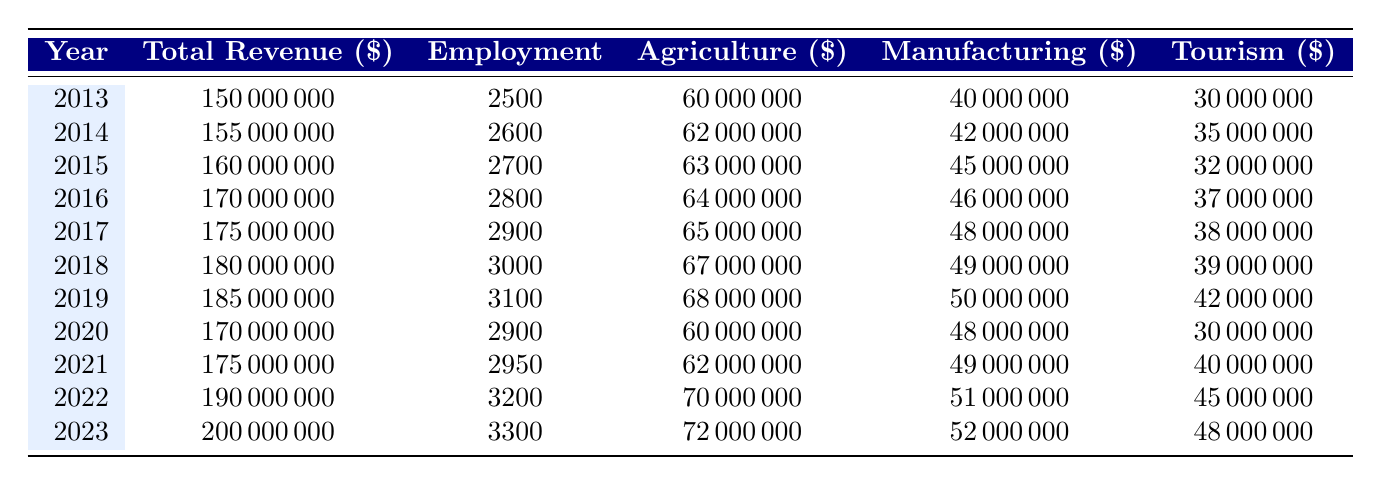What was the total revenue in 2019? The table shows the revenue for each year, and for 2019, it specifically states that the total revenue was 185000000.
Answer: 185000000 What was the employment figure in 2023? Referring to the table, the employment figure listed for the year 2023 is 3300.
Answer: 3300 Which year had the highest agriculture revenue? Reviewing the agriculture revenue column, the highest value listed is for the year 2023, with agriculture revenue of 72000000.
Answer: 2023 What is the total revenue of all local industries from 2013 to 2023? To find the total revenue, sum the total revenue for all the years from 2013 to 2023: 150000000 + 155000000 + 160000000 + 170000000 + 175000000 + 180000000 + 185000000 + 170000000 + 175000000 + 190000000 + 200000000 = 1,880,000,000.
Answer: 1880000000 Is the tourism revenue in 2022 greater than that in 2014? The tourism revenue in 2022 is 45000000 and in 2014, it is 35000000. Since 45000000 is greater than 35000000, the statement is true.
Answer: Yes What was the average manufacturing revenue from 2015 to 2020? To find the average manufacturing revenue, sum the manufacturing revenues from 2015 to 2020: 45000000 + 46000000 + 48000000 + 49000000 + 48000000 = 236000000. Then divide by the number of years (6): 236000000 / 6 = 39333333.33.
Answer: 39333333.33 How much did the total revenue decrease from 2019 to 2020? The total revenue in 2019 was 185000000, and in 2020 it was 170000000. The decrease is calculated by subtracting 170000000 from 185000000, which equals 15000000.
Answer: 15000000 In which year did employment first exceed 3000? Inspecting the employment figures, it first exceeds 3000 in the year 2018, which has an employment figure of 3000.
Answer: 2018 Did agriculture revenue decrease in 2020 compared to 2019? In 2019, agriculture revenue was 68000000, and in 2020 it decreased to 60000000. Thus, the statement is true as there was a decrease.
Answer: Yes 